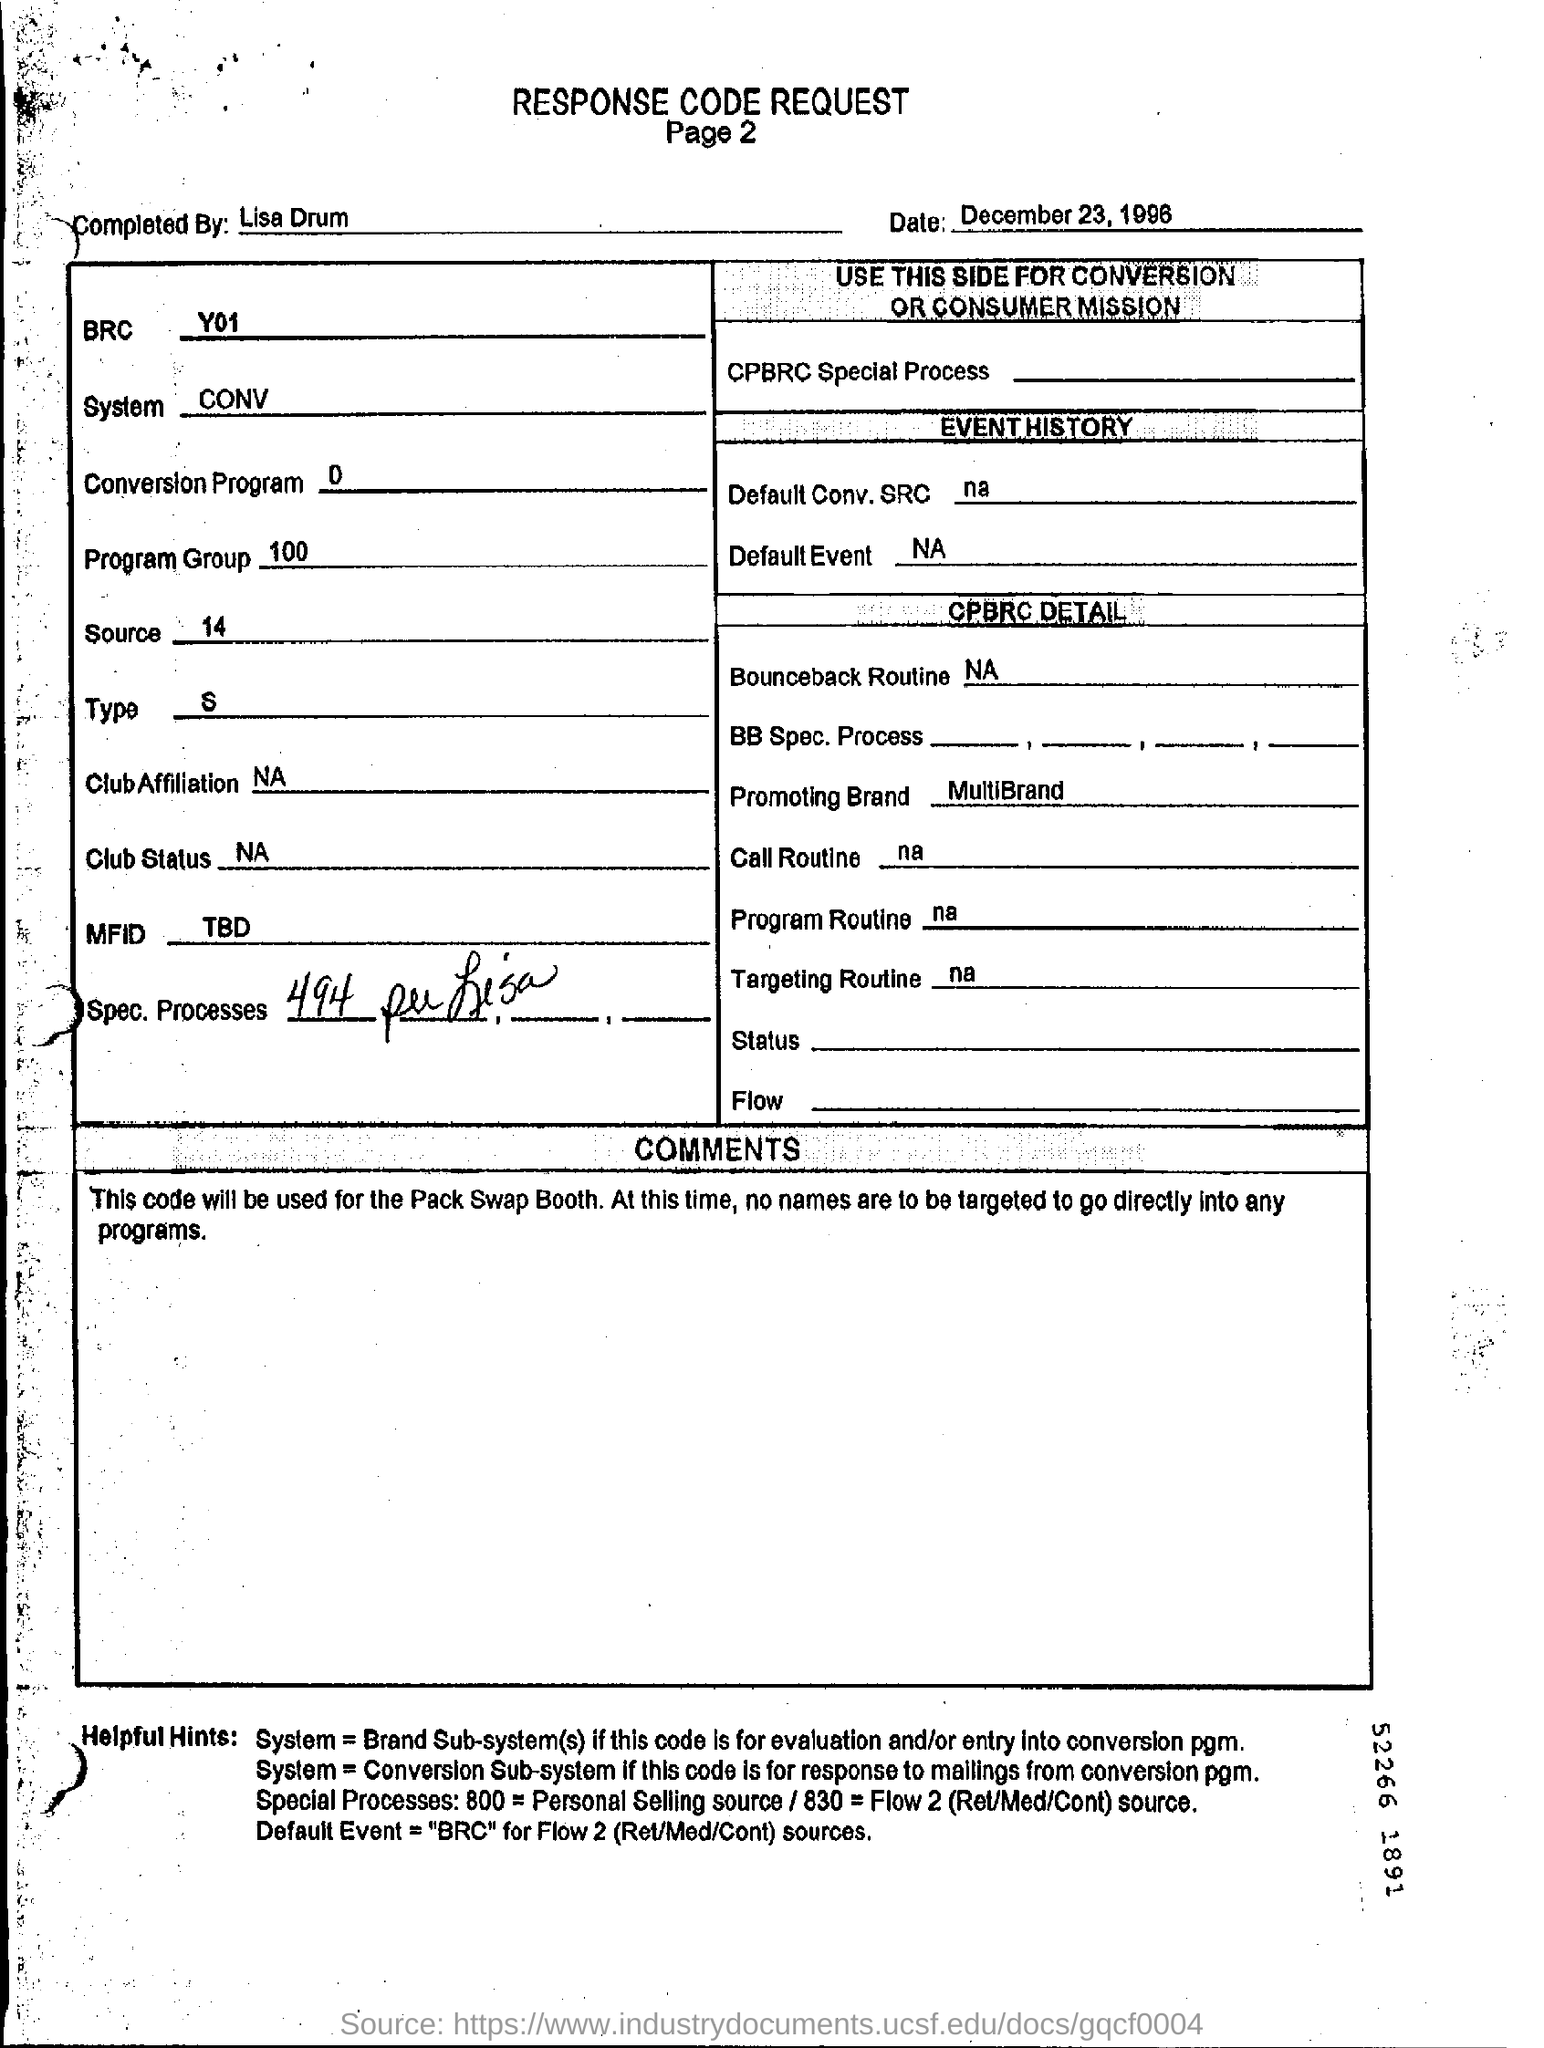Mention a couple of crucial points in this snapshot. The program group mentioned is 100. The "conversion program" as per the form is a specific process or set of instructions that converts a number from one base to another. The range of numbers that can be converted is 0 through 9, which means that this program is designed to convert numbers from 0 to 9, inclusive, to another base. The date mentioned in the request form is December 23, 1996. The form was completed by Lisa Drum. The "source" as per the form is 14. 